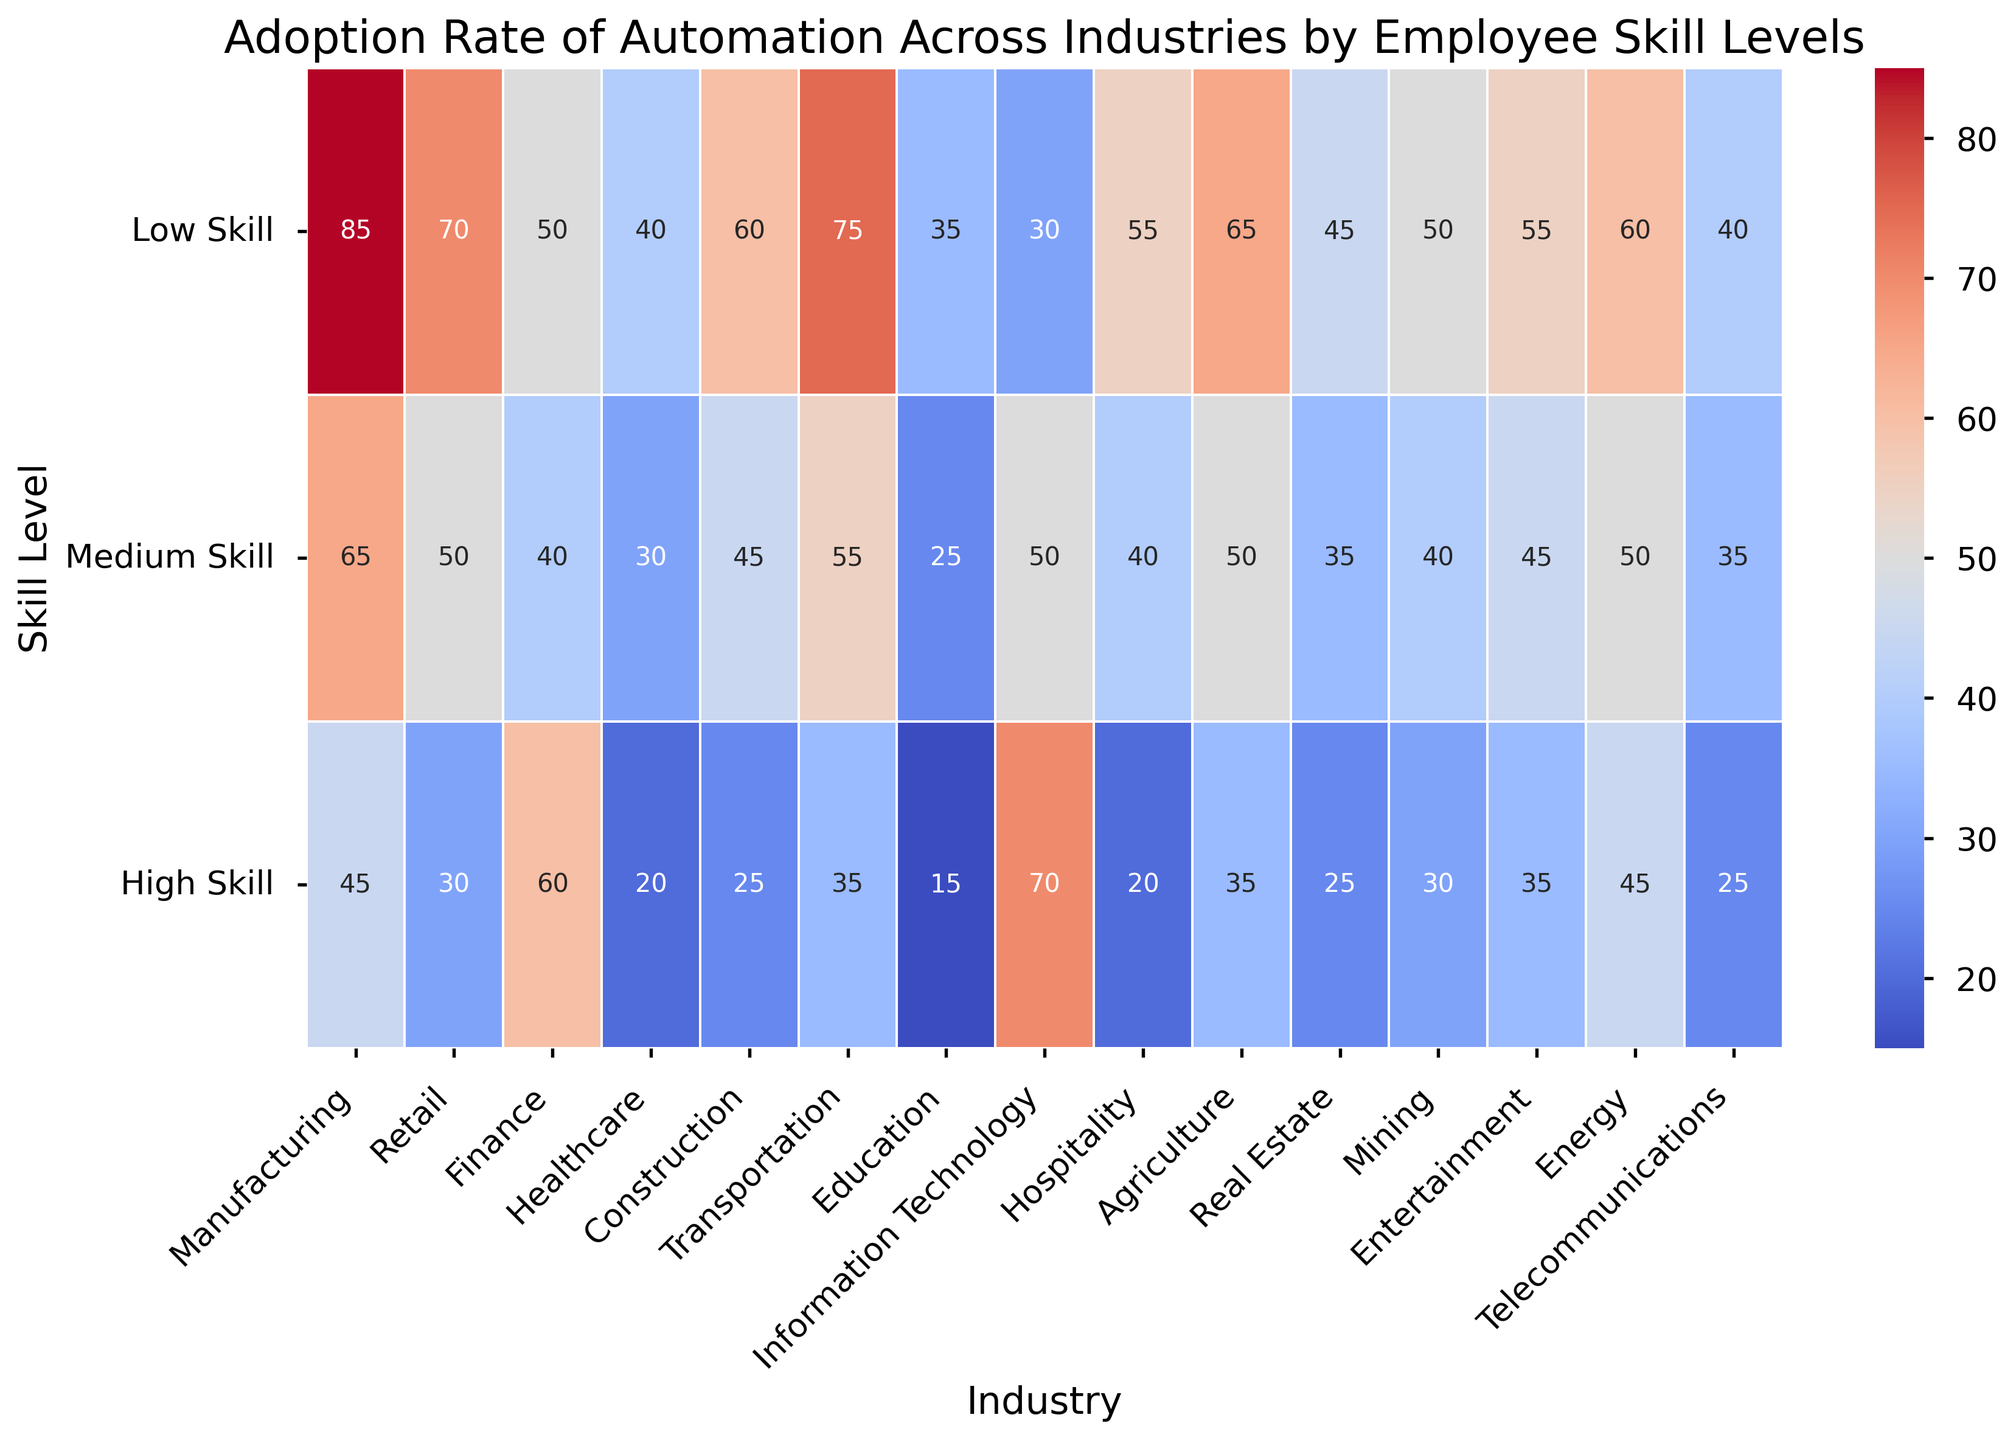What industry has the highest adoption rate of automation for low-skill employees? Look at the heatmap color and values for the low-skill row, find the highest value. Manufacturing has the highest value of 85
Answer: Manufacturing What is the difference in automation adoption rate between high-skill Finance employees and high-skill IT employees? The value for high-skill Finance is 60 and for high-skill IT is 70. The difference is 70 - 60 = 10
Answer: 10 Which industry has the lowest adoption rate of automation across all skill levels? Check all three rows for each industry and find the one with the lowest aggregated value. Education has 35 + 25 + 15 = 75, which is the lowest
Answer: Education Compare the adoption rates of medium-skill employees in Retail and Transportation. Which industry has a higher rate? For medium-skill employees in Retail, the value is 50. In Transportation, it is 55. Transportation has a higher rate
Answer: Transportation Which skill level in the Agricultural industry has the highest adoption rate? Look at the Agriculture column and compare the values for low, medium, and high skill levels. Low skill has the highest value at 65
Answer: Low Skill What is the average adoption rate of automation for high-skill employees across all industries? Sum all values in the high-skill row and divide by the number of industries. (45 + 30 + 60 + 20 + 25 + 35 + 15 + 70 + 20 + 35 + 25 + 30 + 35 + 45 + 25) / 15 = 37.67
Answer: 37.67 Is the adoption rate higher for low-skill employees in Real Estate or Hospitality? For low-skill employees in Real Estate, the value is 45. In Hospitality, it is 55. Hospitality has a higher rate
Answer: Hospitality What industry shows a similar adoption rate for low-skill and medium-skill employees? Look for industries where the values for low-skill and medium-skill rows are close. For Construction, low-skill is 60 and medium-skill is 45, which are relatively close compared to others
Answer: Construction Which industry has the most balanced adoption rate of automation across all skill levels? Look for an industry where the adoption rates for low, medium, and high skill levels are the closest. For Information Technology, the adoption rates are 30, 50, and 70, respectively, showing a balanced distribution
Answer: Information Technology How does the adoption rate for high-skill employees in Mining compare to Medium-skill employees in Entertainment? The high-skill adoption rate in Mining is 30, while the medium-skill rate in Entertainment is 45. Entertainment's rate is higher
Answer: Entertainment 